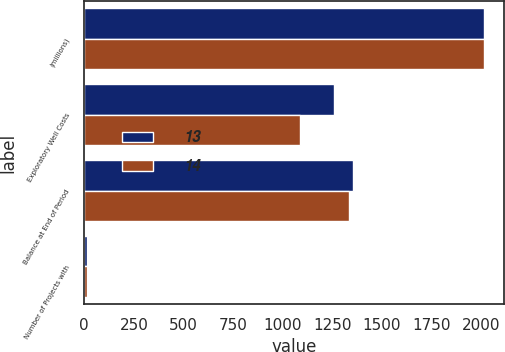Convert chart. <chart><loc_0><loc_0><loc_500><loc_500><stacked_bar_chart><ecel><fcel>(millions)<fcel>Exploratory Well Costs<fcel>Balance at End of Period<fcel>Number of Projects with<nl><fcel>13<fcel>2015<fcel>1258<fcel>1353<fcel>14<nl><fcel>14<fcel>2014<fcel>1090<fcel>1337<fcel>13<nl></chart> 